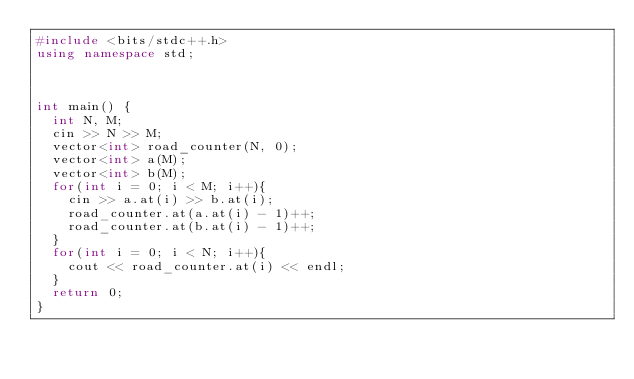<code> <loc_0><loc_0><loc_500><loc_500><_C++_>#include <bits/stdc++.h>
using namespace std;



int main() {
	int N, M;
	cin >> N >> M;
	vector<int> road_counter(N, 0);
	vector<int> a(M);
	vector<int> b(M);
	for(int i = 0; i < M; i++){
		cin >> a.at(i) >> b.at(i);
		road_counter.at(a.at(i) - 1)++;
		road_counter.at(b.at(i) - 1)++;
	}
	for(int i = 0; i < N; i++){
		cout << road_counter.at(i) << endl;
	}
	return 0;
}</code> 